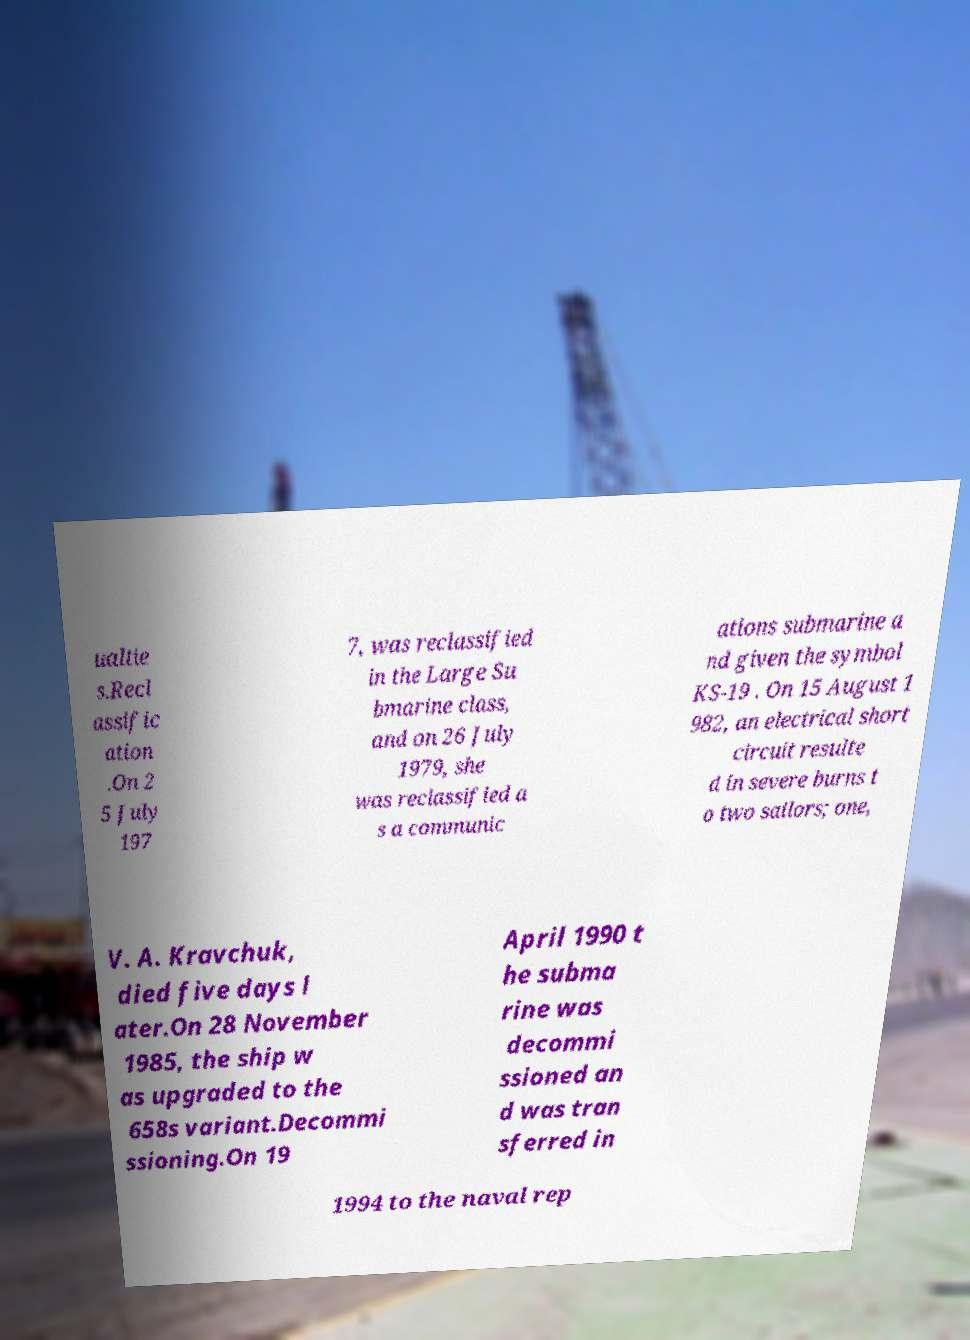I need the written content from this picture converted into text. Can you do that? ualtie s.Recl assific ation .On 2 5 July 197 7, was reclassified in the Large Su bmarine class, and on 26 July 1979, she was reclassified a s a communic ations submarine a nd given the symbol KS-19 . On 15 August 1 982, an electrical short circuit resulte d in severe burns t o two sailors; one, V. A. Kravchuk, died five days l ater.On 28 November 1985, the ship w as upgraded to the 658s variant.Decommi ssioning.On 19 April 1990 t he subma rine was decommi ssioned an d was tran sferred in 1994 to the naval rep 